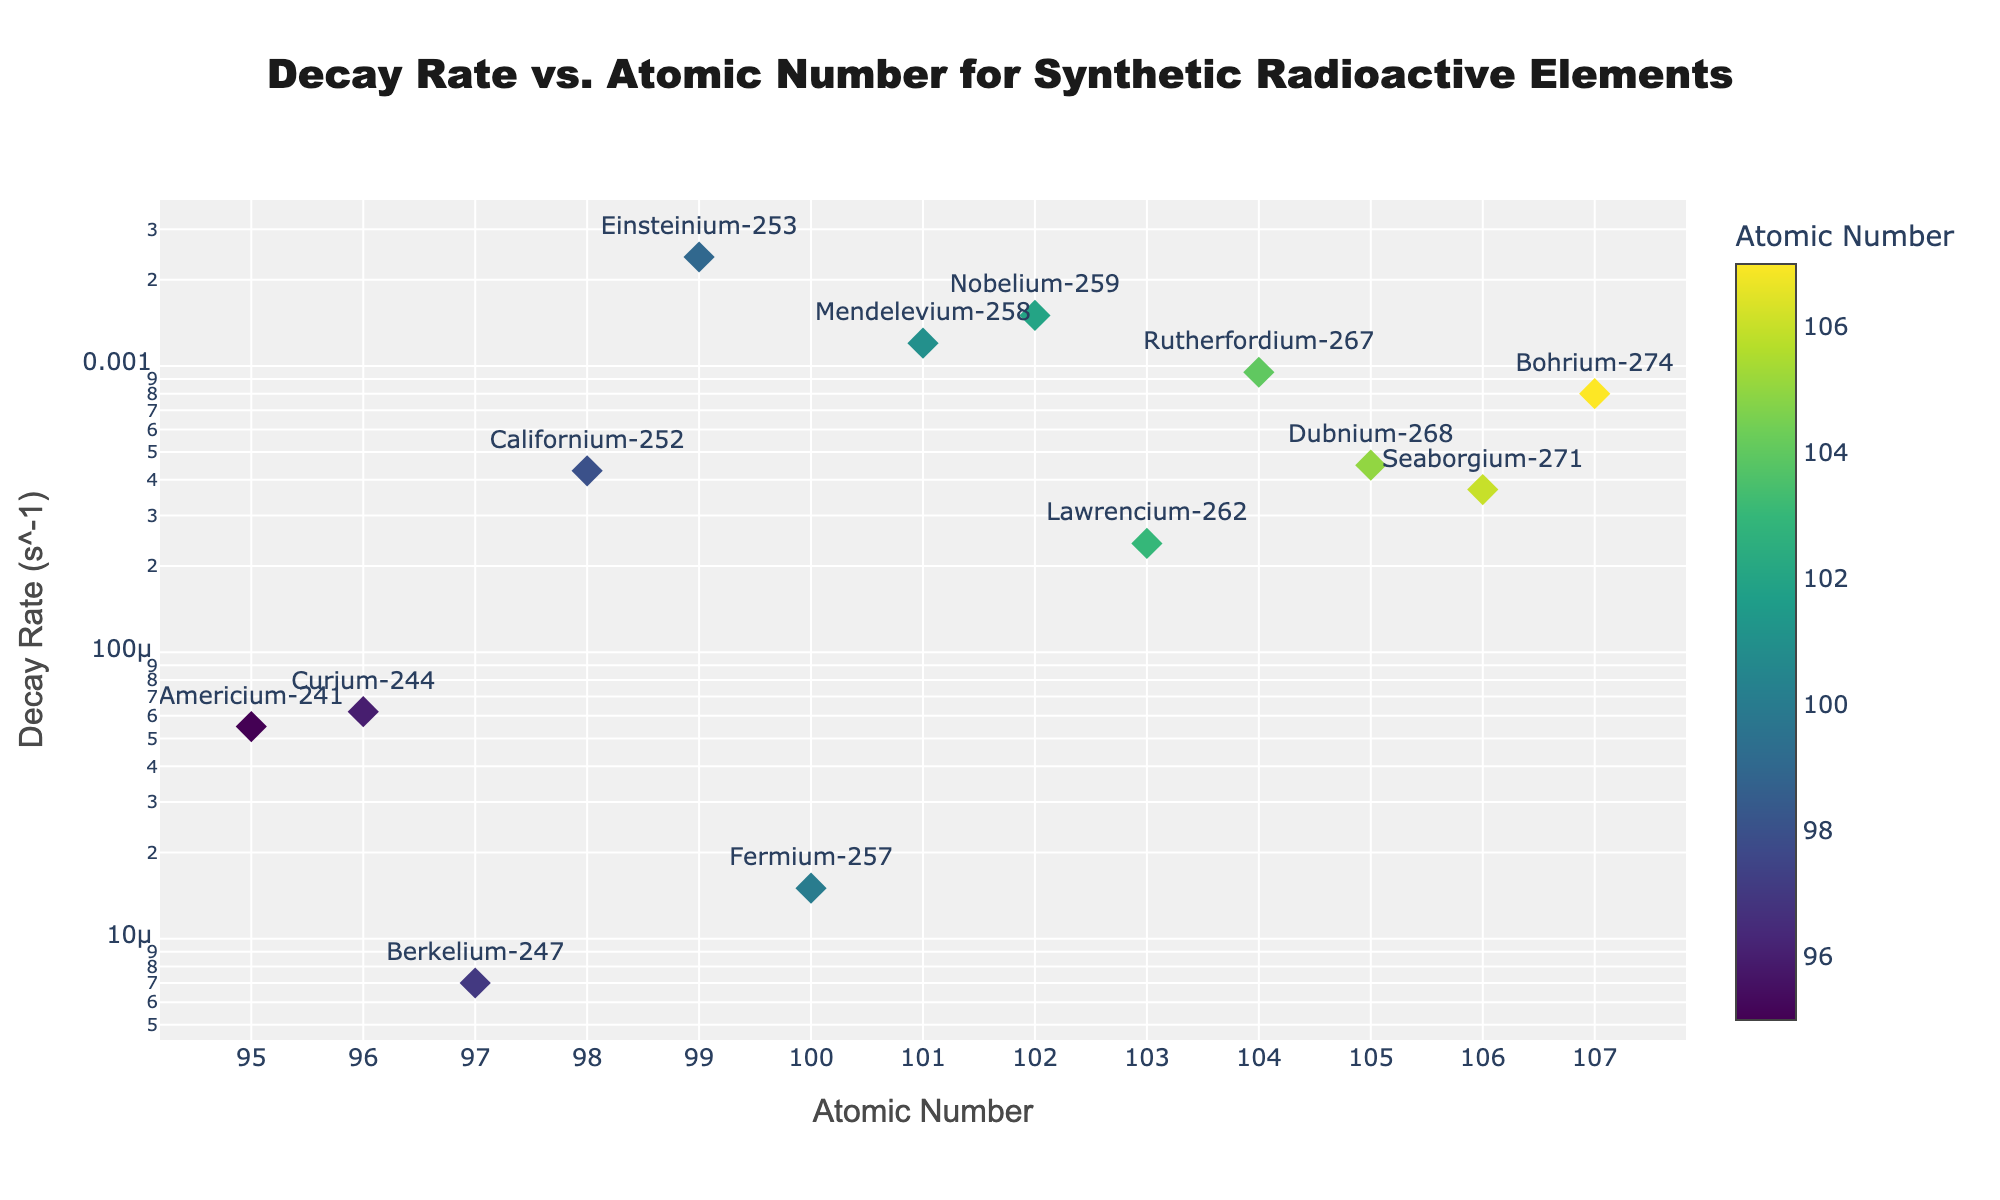What's the title of the plot? The title of the plot is easily found at the top center of the figure. It reads: 'Decay Rate vs. Atomic Number for Synthetic Radioactive Elements'.
Answer: Decay Rate vs. Atomic Number for Synthetic Radioactive Elements How many data points are displayed in the plot? By counting the markers in the plot, we find that each one represents a synthetic radioactive element. In total, there are 13 data points or markers.
Answer: 13 What is the atomic number and decay rate of the element with the highest decay rate? The hover information in the plot shows that the element with the highest decay rate is Einsteinium-253, which has an atomic number of 99 and a decay rate of 2.4e-03 s^-1.
Answer: Einsteinium-253 (Atomic Number: 99, Decay Rate: 2.4e-03 s^-1) Which element has the lowest decay rate and what is its value? By examining the y-axis logarithmic scale and the position of the markers, Berkelium-247 is identified as having the lowest decay rate of 7.0e-06 s^-1.
Answer: Berkelium-247 (7.0e-06 s^-1) How does the decay rate of Californium-252 compare to Dubnium-268? The decay rate of Californium-252 is 4.3e-04 s^-1, while Dubnium-268 has a decay rate of 4.5e-04 s^-1. Comparing these values, Dubnium-268 has a slightly higher decay rate than Californium-252.
Answer: Dubnium-268 has a higher decay rate What's the average decay rate of elements with an atomic number greater than 100? Firstly, identify the elements with atomic numbers: 101 (1.2e-03), 102 (1.5e-03), 103 (2.4e-04), 104 (9.5e-04), 105 (4.5e-04), 106 (3.7e-04), 107 (8.0e-04). Sum their decay rates: 1.2e-03 + 1.5e-03 + 2.4e-04 + 9.5e-04 + 4.5e-04 + 3.7e-04 + 8.0e-04 = 6.68e-03. Then, divide by the number of elements (7): 6.68e-03/7 = 9.54e-04.
Answer: 9.54e-04 s^-1 What kind of scale is used for the y-axis representing the decay rates? By looking at the y-axis, it is evident that the scale is logarithmic, which allows for a better visualization of a wide range of decay rates.
Answer: Logarithmic What is the range of atomic numbers present in the plot? By examining the x-axis, the atomic numbers of the elements range from a minimum of 95 (Americium-241) to a maximum of 107 (Bohrium-274).
Answer: 95 to 107 Which element has a decay rate closest to 1.0e-03 s^-1 and what is its atomic number? Looking at the markers and their hover information, Nobelium-259 has a decay rate of 1.5e-03 s^-1, which is the closest data point to 1.0e-03 s^-1. Its atomic number is 102.
Answer: Nobelium-259 (Atomic Number: 102) 